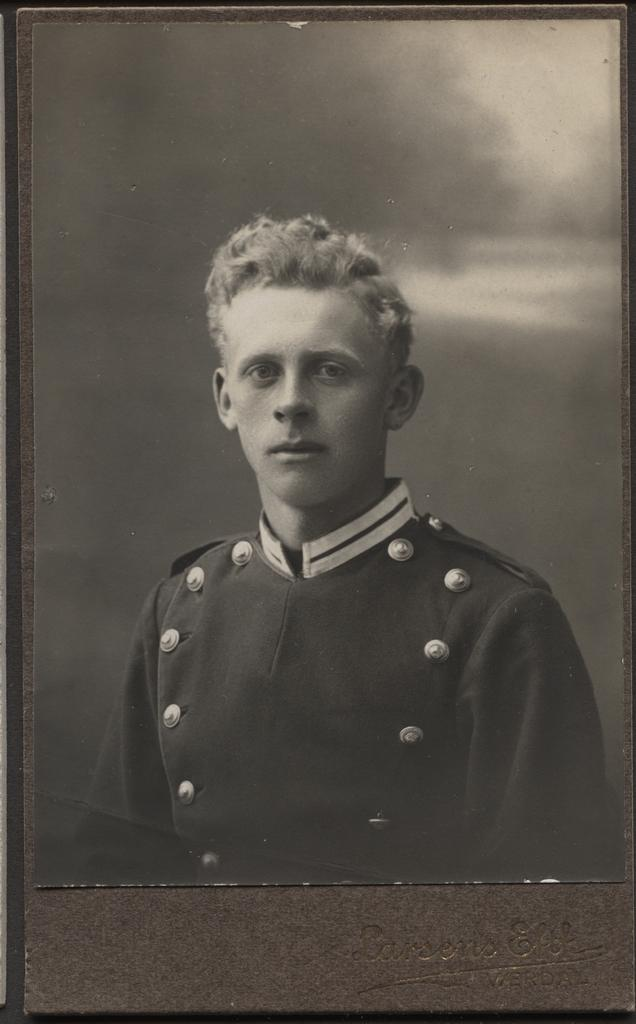What is the main subject of the image? There is a photo in the image. Who or what can be seen in the photo? The photo contains a man. What can be seen in the background of the photo? The sky is visible in the photo. How many cows are visible in the photo? There are no cows visible in the photo; it contains a man and the sky. What type of guitar is the man playing in the photo? There is no guitar present in the photo; it only contains a man and the sky. 